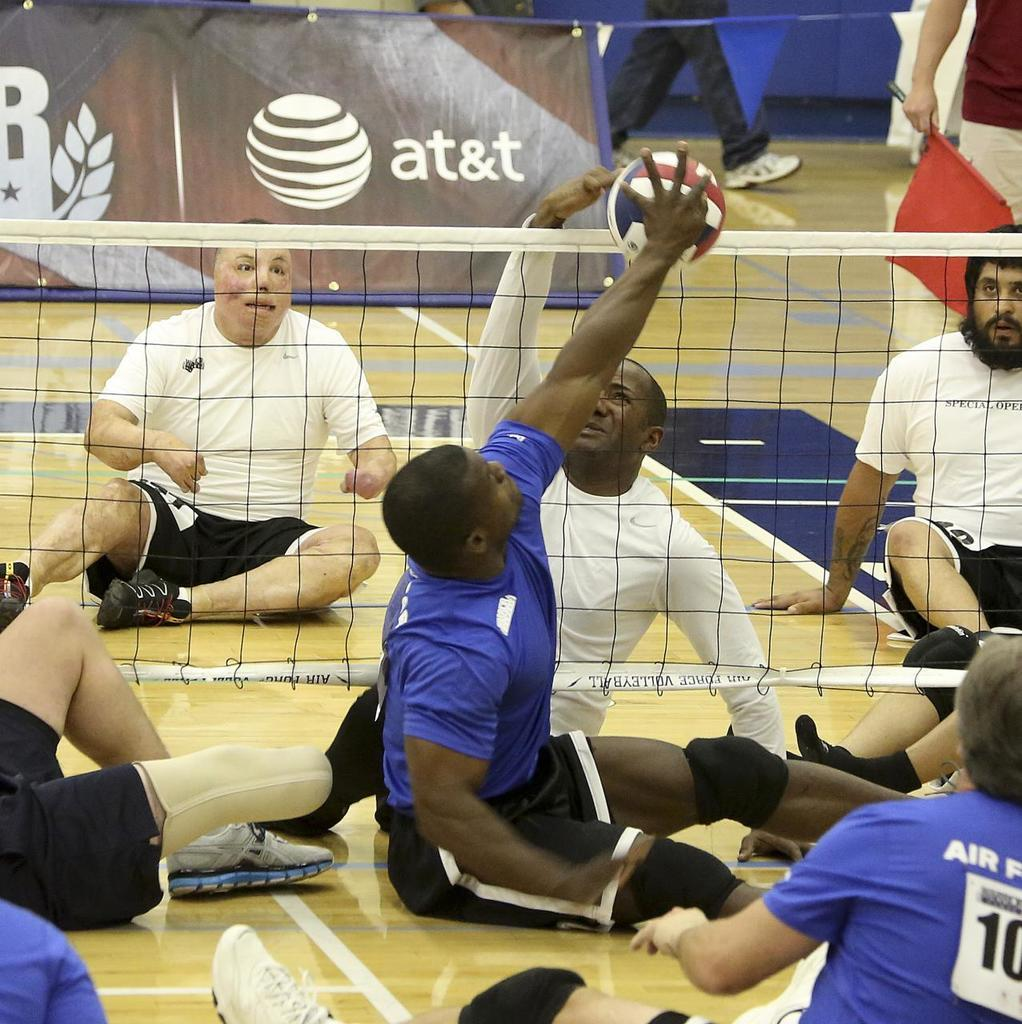What are the people in the image doing? The people in the image are sitting on the ground and playing with a ball. What object is present in the image that might be used for a game? There is a net in the image, which could be used for a game like volleyball. What can be seen in the background of the image? There are people walking in the background of the image. What type of industry can be seen in the image? There is no industry present in the image; it features people playing with a ball and a net. What smell is associated with the plants in the image? There are no plants present in the image, so it is not possible to determine any associated smells. 